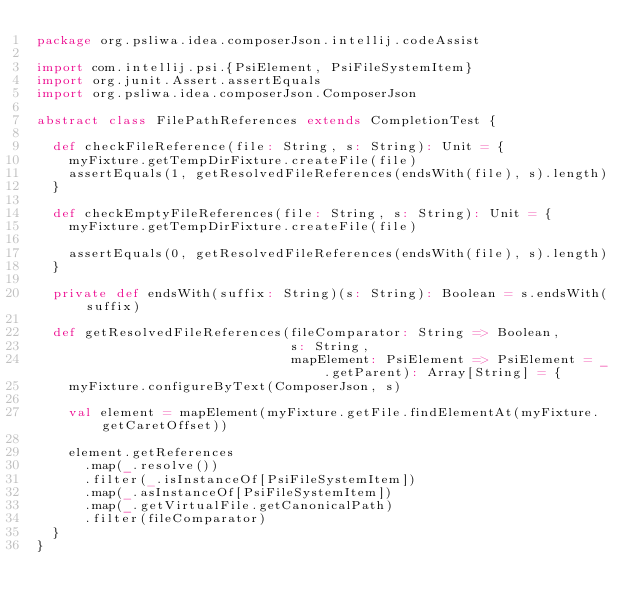<code> <loc_0><loc_0><loc_500><loc_500><_Scala_>package org.psliwa.idea.composerJson.intellij.codeAssist

import com.intellij.psi.{PsiElement, PsiFileSystemItem}
import org.junit.Assert.assertEquals
import org.psliwa.idea.composerJson.ComposerJson

abstract class FilePathReferences extends CompletionTest {

  def checkFileReference(file: String, s: String): Unit = {
    myFixture.getTempDirFixture.createFile(file)
    assertEquals(1, getResolvedFileReferences(endsWith(file), s).length)
  }

  def checkEmptyFileReferences(file: String, s: String): Unit = {
    myFixture.getTempDirFixture.createFile(file)

    assertEquals(0, getResolvedFileReferences(endsWith(file), s).length)
  }

  private def endsWith(suffix: String)(s: String): Boolean = s.endsWith(suffix)

  def getResolvedFileReferences(fileComparator: String => Boolean,
                                s: String,
                                mapElement: PsiElement => PsiElement = _.getParent): Array[String] = {
    myFixture.configureByText(ComposerJson, s)

    val element = mapElement(myFixture.getFile.findElementAt(myFixture.getCaretOffset))

    element.getReferences
      .map(_.resolve())
      .filter(_.isInstanceOf[PsiFileSystemItem])
      .map(_.asInstanceOf[PsiFileSystemItem])
      .map(_.getVirtualFile.getCanonicalPath)
      .filter(fileComparator)
  }
}
</code> 